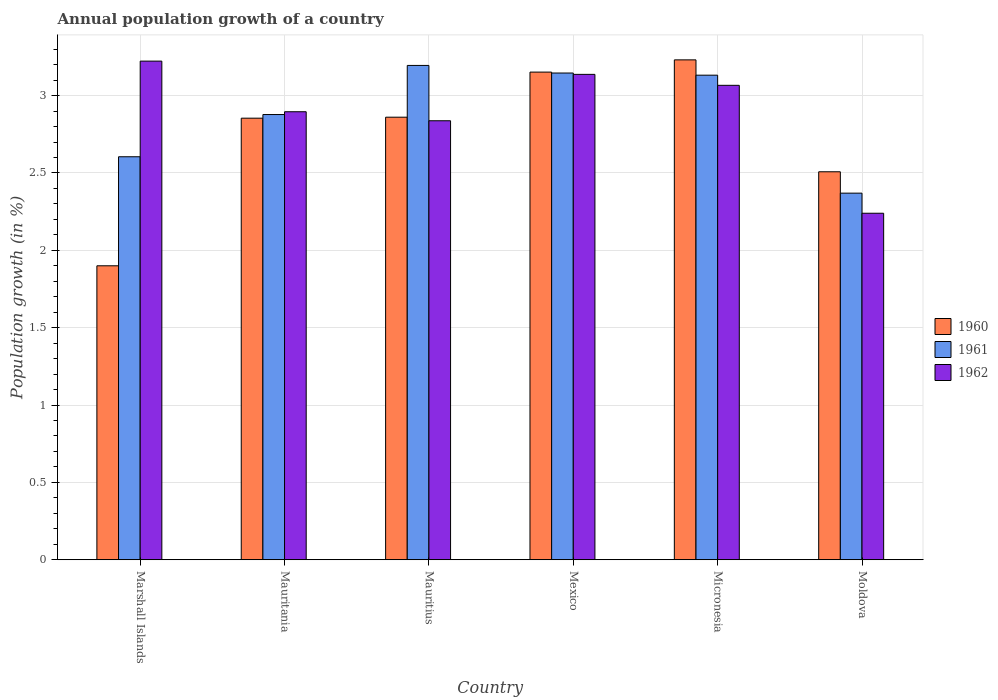How many different coloured bars are there?
Make the answer very short. 3. How many groups of bars are there?
Offer a terse response. 6. Are the number of bars on each tick of the X-axis equal?
Ensure brevity in your answer.  Yes. How many bars are there on the 1st tick from the right?
Your answer should be very brief. 3. What is the label of the 5th group of bars from the left?
Offer a very short reply. Micronesia. In how many cases, is the number of bars for a given country not equal to the number of legend labels?
Offer a terse response. 0. What is the annual population growth in 1962 in Mauritania?
Give a very brief answer. 2.9. Across all countries, what is the maximum annual population growth in 1962?
Make the answer very short. 3.22. Across all countries, what is the minimum annual population growth in 1962?
Offer a terse response. 2.24. In which country was the annual population growth in 1962 maximum?
Offer a terse response. Marshall Islands. In which country was the annual population growth in 1961 minimum?
Provide a short and direct response. Moldova. What is the total annual population growth in 1962 in the graph?
Offer a terse response. 17.4. What is the difference between the annual population growth in 1960 in Marshall Islands and that in Mauritania?
Keep it short and to the point. -0.95. What is the difference between the annual population growth in 1961 in Mexico and the annual population growth in 1960 in Mauritius?
Your answer should be very brief. 0.29. What is the average annual population growth in 1960 per country?
Offer a terse response. 2.75. What is the difference between the annual population growth of/in 1961 and annual population growth of/in 1960 in Mauritius?
Make the answer very short. 0.33. In how many countries, is the annual population growth in 1961 greater than 0.9 %?
Provide a short and direct response. 6. What is the ratio of the annual population growth in 1962 in Marshall Islands to that in Mauritania?
Offer a terse response. 1.11. What is the difference between the highest and the second highest annual population growth in 1961?
Give a very brief answer. -0.05. What is the difference between the highest and the lowest annual population growth in 1960?
Make the answer very short. 1.33. In how many countries, is the annual population growth in 1961 greater than the average annual population growth in 1961 taken over all countries?
Your response must be concise. 3. Is it the case that in every country, the sum of the annual population growth in 1962 and annual population growth in 1961 is greater than the annual population growth in 1960?
Your answer should be compact. Yes. How many bars are there?
Give a very brief answer. 18. Does the graph contain any zero values?
Give a very brief answer. No. How many legend labels are there?
Your answer should be very brief. 3. What is the title of the graph?
Your response must be concise. Annual population growth of a country. What is the label or title of the Y-axis?
Ensure brevity in your answer.  Population growth (in %). What is the Population growth (in %) in 1960 in Marshall Islands?
Your answer should be compact. 1.9. What is the Population growth (in %) of 1961 in Marshall Islands?
Provide a succinct answer. 2.6. What is the Population growth (in %) in 1962 in Marshall Islands?
Offer a terse response. 3.22. What is the Population growth (in %) of 1960 in Mauritania?
Keep it short and to the point. 2.85. What is the Population growth (in %) in 1961 in Mauritania?
Make the answer very short. 2.88. What is the Population growth (in %) of 1962 in Mauritania?
Give a very brief answer. 2.9. What is the Population growth (in %) of 1960 in Mauritius?
Make the answer very short. 2.86. What is the Population growth (in %) of 1961 in Mauritius?
Keep it short and to the point. 3.19. What is the Population growth (in %) of 1962 in Mauritius?
Your response must be concise. 2.84. What is the Population growth (in %) of 1960 in Mexico?
Offer a terse response. 3.15. What is the Population growth (in %) of 1961 in Mexico?
Your response must be concise. 3.15. What is the Population growth (in %) of 1962 in Mexico?
Offer a terse response. 3.14. What is the Population growth (in %) of 1960 in Micronesia?
Offer a very short reply. 3.23. What is the Population growth (in %) of 1961 in Micronesia?
Ensure brevity in your answer.  3.13. What is the Population growth (in %) of 1962 in Micronesia?
Ensure brevity in your answer.  3.07. What is the Population growth (in %) in 1960 in Moldova?
Provide a succinct answer. 2.51. What is the Population growth (in %) of 1961 in Moldova?
Your answer should be very brief. 2.37. What is the Population growth (in %) in 1962 in Moldova?
Offer a terse response. 2.24. Across all countries, what is the maximum Population growth (in %) in 1960?
Provide a short and direct response. 3.23. Across all countries, what is the maximum Population growth (in %) in 1961?
Your response must be concise. 3.19. Across all countries, what is the maximum Population growth (in %) in 1962?
Ensure brevity in your answer.  3.22. Across all countries, what is the minimum Population growth (in %) of 1960?
Provide a short and direct response. 1.9. Across all countries, what is the minimum Population growth (in %) of 1961?
Your answer should be compact. 2.37. Across all countries, what is the minimum Population growth (in %) of 1962?
Your answer should be very brief. 2.24. What is the total Population growth (in %) in 1960 in the graph?
Make the answer very short. 16.5. What is the total Population growth (in %) in 1961 in the graph?
Your answer should be compact. 17.32. What is the total Population growth (in %) of 1962 in the graph?
Offer a very short reply. 17.4. What is the difference between the Population growth (in %) of 1960 in Marshall Islands and that in Mauritania?
Provide a succinct answer. -0.95. What is the difference between the Population growth (in %) of 1961 in Marshall Islands and that in Mauritania?
Offer a very short reply. -0.27. What is the difference between the Population growth (in %) of 1962 in Marshall Islands and that in Mauritania?
Your response must be concise. 0.33. What is the difference between the Population growth (in %) in 1960 in Marshall Islands and that in Mauritius?
Give a very brief answer. -0.96. What is the difference between the Population growth (in %) of 1961 in Marshall Islands and that in Mauritius?
Ensure brevity in your answer.  -0.59. What is the difference between the Population growth (in %) in 1962 in Marshall Islands and that in Mauritius?
Your response must be concise. 0.39. What is the difference between the Population growth (in %) of 1960 in Marshall Islands and that in Mexico?
Make the answer very short. -1.25. What is the difference between the Population growth (in %) of 1961 in Marshall Islands and that in Mexico?
Provide a succinct answer. -0.54. What is the difference between the Population growth (in %) in 1962 in Marshall Islands and that in Mexico?
Give a very brief answer. 0.09. What is the difference between the Population growth (in %) in 1960 in Marshall Islands and that in Micronesia?
Your answer should be compact. -1.33. What is the difference between the Population growth (in %) in 1961 in Marshall Islands and that in Micronesia?
Provide a succinct answer. -0.53. What is the difference between the Population growth (in %) of 1962 in Marshall Islands and that in Micronesia?
Give a very brief answer. 0.16. What is the difference between the Population growth (in %) of 1960 in Marshall Islands and that in Moldova?
Make the answer very short. -0.61. What is the difference between the Population growth (in %) in 1961 in Marshall Islands and that in Moldova?
Offer a terse response. 0.24. What is the difference between the Population growth (in %) of 1962 in Marshall Islands and that in Moldova?
Give a very brief answer. 0.98. What is the difference between the Population growth (in %) of 1960 in Mauritania and that in Mauritius?
Provide a succinct answer. -0.01. What is the difference between the Population growth (in %) of 1961 in Mauritania and that in Mauritius?
Offer a terse response. -0.32. What is the difference between the Population growth (in %) of 1962 in Mauritania and that in Mauritius?
Provide a short and direct response. 0.06. What is the difference between the Population growth (in %) in 1960 in Mauritania and that in Mexico?
Keep it short and to the point. -0.3. What is the difference between the Population growth (in %) in 1961 in Mauritania and that in Mexico?
Your response must be concise. -0.27. What is the difference between the Population growth (in %) in 1962 in Mauritania and that in Mexico?
Ensure brevity in your answer.  -0.24. What is the difference between the Population growth (in %) of 1960 in Mauritania and that in Micronesia?
Give a very brief answer. -0.38. What is the difference between the Population growth (in %) of 1961 in Mauritania and that in Micronesia?
Offer a terse response. -0.25. What is the difference between the Population growth (in %) of 1962 in Mauritania and that in Micronesia?
Your response must be concise. -0.17. What is the difference between the Population growth (in %) of 1960 in Mauritania and that in Moldova?
Ensure brevity in your answer.  0.35. What is the difference between the Population growth (in %) of 1961 in Mauritania and that in Moldova?
Your answer should be very brief. 0.51. What is the difference between the Population growth (in %) in 1962 in Mauritania and that in Moldova?
Make the answer very short. 0.66. What is the difference between the Population growth (in %) in 1960 in Mauritius and that in Mexico?
Give a very brief answer. -0.29. What is the difference between the Population growth (in %) of 1961 in Mauritius and that in Mexico?
Your response must be concise. 0.05. What is the difference between the Population growth (in %) of 1962 in Mauritius and that in Mexico?
Provide a succinct answer. -0.3. What is the difference between the Population growth (in %) in 1960 in Mauritius and that in Micronesia?
Offer a very short reply. -0.37. What is the difference between the Population growth (in %) in 1961 in Mauritius and that in Micronesia?
Provide a succinct answer. 0.06. What is the difference between the Population growth (in %) in 1962 in Mauritius and that in Micronesia?
Offer a very short reply. -0.23. What is the difference between the Population growth (in %) of 1960 in Mauritius and that in Moldova?
Give a very brief answer. 0.35. What is the difference between the Population growth (in %) in 1961 in Mauritius and that in Moldova?
Give a very brief answer. 0.83. What is the difference between the Population growth (in %) in 1962 in Mauritius and that in Moldova?
Offer a terse response. 0.6. What is the difference between the Population growth (in %) of 1960 in Mexico and that in Micronesia?
Your answer should be compact. -0.08. What is the difference between the Population growth (in %) in 1961 in Mexico and that in Micronesia?
Keep it short and to the point. 0.01. What is the difference between the Population growth (in %) of 1962 in Mexico and that in Micronesia?
Give a very brief answer. 0.07. What is the difference between the Population growth (in %) in 1960 in Mexico and that in Moldova?
Provide a short and direct response. 0.64. What is the difference between the Population growth (in %) in 1961 in Mexico and that in Moldova?
Provide a short and direct response. 0.78. What is the difference between the Population growth (in %) in 1962 in Mexico and that in Moldova?
Offer a terse response. 0.9. What is the difference between the Population growth (in %) of 1960 in Micronesia and that in Moldova?
Give a very brief answer. 0.72. What is the difference between the Population growth (in %) in 1961 in Micronesia and that in Moldova?
Your answer should be very brief. 0.76. What is the difference between the Population growth (in %) in 1962 in Micronesia and that in Moldova?
Provide a short and direct response. 0.83. What is the difference between the Population growth (in %) of 1960 in Marshall Islands and the Population growth (in %) of 1961 in Mauritania?
Offer a terse response. -0.98. What is the difference between the Population growth (in %) of 1960 in Marshall Islands and the Population growth (in %) of 1962 in Mauritania?
Provide a succinct answer. -1. What is the difference between the Population growth (in %) in 1961 in Marshall Islands and the Population growth (in %) in 1962 in Mauritania?
Make the answer very short. -0.29. What is the difference between the Population growth (in %) in 1960 in Marshall Islands and the Population growth (in %) in 1961 in Mauritius?
Provide a short and direct response. -1.29. What is the difference between the Population growth (in %) in 1960 in Marshall Islands and the Population growth (in %) in 1962 in Mauritius?
Give a very brief answer. -0.94. What is the difference between the Population growth (in %) of 1961 in Marshall Islands and the Population growth (in %) of 1962 in Mauritius?
Give a very brief answer. -0.23. What is the difference between the Population growth (in %) in 1960 in Marshall Islands and the Population growth (in %) in 1961 in Mexico?
Offer a terse response. -1.25. What is the difference between the Population growth (in %) in 1960 in Marshall Islands and the Population growth (in %) in 1962 in Mexico?
Your answer should be very brief. -1.24. What is the difference between the Population growth (in %) of 1961 in Marshall Islands and the Population growth (in %) of 1962 in Mexico?
Keep it short and to the point. -0.53. What is the difference between the Population growth (in %) of 1960 in Marshall Islands and the Population growth (in %) of 1961 in Micronesia?
Provide a succinct answer. -1.23. What is the difference between the Population growth (in %) of 1960 in Marshall Islands and the Population growth (in %) of 1962 in Micronesia?
Make the answer very short. -1.17. What is the difference between the Population growth (in %) in 1961 in Marshall Islands and the Population growth (in %) in 1962 in Micronesia?
Ensure brevity in your answer.  -0.46. What is the difference between the Population growth (in %) in 1960 in Marshall Islands and the Population growth (in %) in 1961 in Moldova?
Provide a short and direct response. -0.47. What is the difference between the Population growth (in %) in 1960 in Marshall Islands and the Population growth (in %) in 1962 in Moldova?
Your answer should be very brief. -0.34. What is the difference between the Population growth (in %) in 1961 in Marshall Islands and the Population growth (in %) in 1962 in Moldova?
Your response must be concise. 0.37. What is the difference between the Population growth (in %) of 1960 in Mauritania and the Population growth (in %) of 1961 in Mauritius?
Your answer should be compact. -0.34. What is the difference between the Population growth (in %) of 1960 in Mauritania and the Population growth (in %) of 1962 in Mauritius?
Provide a short and direct response. 0.02. What is the difference between the Population growth (in %) in 1961 in Mauritania and the Population growth (in %) in 1962 in Mauritius?
Your response must be concise. 0.04. What is the difference between the Population growth (in %) in 1960 in Mauritania and the Population growth (in %) in 1961 in Mexico?
Give a very brief answer. -0.29. What is the difference between the Population growth (in %) of 1960 in Mauritania and the Population growth (in %) of 1962 in Mexico?
Provide a short and direct response. -0.28. What is the difference between the Population growth (in %) of 1961 in Mauritania and the Population growth (in %) of 1962 in Mexico?
Make the answer very short. -0.26. What is the difference between the Population growth (in %) in 1960 in Mauritania and the Population growth (in %) in 1961 in Micronesia?
Your response must be concise. -0.28. What is the difference between the Population growth (in %) in 1960 in Mauritania and the Population growth (in %) in 1962 in Micronesia?
Provide a succinct answer. -0.21. What is the difference between the Population growth (in %) in 1961 in Mauritania and the Population growth (in %) in 1962 in Micronesia?
Your answer should be compact. -0.19. What is the difference between the Population growth (in %) of 1960 in Mauritania and the Population growth (in %) of 1961 in Moldova?
Give a very brief answer. 0.48. What is the difference between the Population growth (in %) of 1960 in Mauritania and the Population growth (in %) of 1962 in Moldova?
Give a very brief answer. 0.61. What is the difference between the Population growth (in %) in 1961 in Mauritania and the Population growth (in %) in 1962 in Moldova?
Make the answer very short. 0.64. What is the difference between the Population growth (in %) of 1960 in Mauritius and the Population growth (in %) of 1961 in Mexico?
Your answer should be compact. -0.29. What is the difference between the Population growth (in %) in 1960 in Mauritius and the Population growth (in %) in 1962 in Mexico?
Make the answer very short. -0.28. What is the difference between the Population growth (in %) in 1961 in Mauritius and the Population growth (in %) in 1962 in Mexico?
Offer a terse response. 0.06. What is the difference between the Population growth (in %) in 1960 in Mauritius and the Population growth (in %) in 1961 in Micronesia?
Your answer should be compact. -0.27. What is the difference between the Population growth (in %) in 1960 in Mauritius and the Population growth (in %) in 1962 in Micronesia?
Provide a short and direct response. -0.21. What is the difference between the Population growth (in %) of 1961 in Mauritius and the Population growth (in %) of 1962 in Micronesia?
Offer a terse response. 0.13. What is the difference between the Population growth (in %) of 1960 in Mauritius and the Population growth (in %) of 1961 in Moldova?
Offer a terse response. 0.49. What is the difference between the Population growth (in %) in 1960 in Mauritius and the Population growth (in %) in 1962 in Moldova?
Your response must be concise. 0.62. What is the difference between the Population growth (in %) in 1961 in Mauritius and the Population growth (in %) in 1962 in Moldova?
Ensure brevity in your answer.  0.96. What is the difference between the Population growth (in %) in 1960 in Mexico and the Population growth (in %) in 1961 in Micronesia?
Your answer should be very brief. 0.02. What is the difference between the Population growth (in %) of 1960 in Mexico and the Population growth (in %) of 1962 in Micronesia?
Offer a terse response. 0.09. What is the difference between the Population growth (in %) of 1961 in Mexico and the Population growth (in %) of 1962 in Micronesia?
Provide a succinct answer. 0.08. What is the difference between the Population growth (in %) in 1960 in Mexico and the Population growth (in %) in 1961 in Moldova?
Offer a very short reply. 0.78. What is the difference between the Population growth (in %) in 1960 in Mexico and the Population growth (in %) in 1962 in Moldova?
Your response must be concise. 0.91. What is the difference between the Population growth (in %) of 1961 in Mexico and the Population growth (in %) of 1962 in Moldova?
Ensure brevity in your answer.  0.91. What is the difference between the Population growth (in %) of 1960 in Micronesia and the Population growth (in %) of 1961 in Moldova?
Give a very brief answer. 0.86. What is the difference between the Population growth (in %) of 1961 in Micronesia and the Population growth (in %) of 1962 in Moldova?
Give a very brief answer. 0.89. What is the average Population growth (in %) of 1960 per country?
Provide a short and direct response. 2.75. What is the average Population growth (in %) of 1961 per country?
Your response must be concise. 2.89. What is the average Population growth (in %) in 1962 per country?
Offer a very short reply. 2.9. What is the difference between the Population growth (in %) of 1960 and Population growth (in %) of 1961 in Marshall Islands?
Your answer should be very brief. -0.7. What is the difference between the Population growth (in %) of 1960 and Population growth (in %) of 1962 in Marshall Islands?
Your answer should be compact. -1.32. What is the difference between the Population growth (in %) of 1961 and Population growth (in %) of 1962 in Marshall Islands?
Provide a succinct answer. -0.62. What is the difference between the Population growth (in %) of 1960 and Population growth (in %) of 1961 in Mauritania?
Provide a short and direct response. -0.02. What is the difference between the Population growth (in %) in 1960 and Population growth (in %) in 1962 in Mauritania?
Your answer should be very brief. -0.04. What is the difference between the Population growth (in %) of 1961 and Population growth (in %) of 1962 in Mauritania?
Offer a terse response. -0.02. What is the difference between the Population growth (in %) in 1960 and Population growth (in %) in 1961 in Mauritius?
Your answer should be compact. -0.33. What is the difference between the Population growth (in %) of 1960 and Population growth (in %) of 1962 in Mauritius?
Your response must be concise. 0.02. What is the difference between the Population growth (in %) in 1961 and Population growth (in %) in 1962 in Mauritius?
Offer a terse response. 0.36. What is the difference between the Population growth (in %) of 1960 and Population growth (in %) of 1961 in Mexico?
Your response must be concise. 0.01. What is the difference between the Population growth (in %) of 1960 and Population growth (in %) of 1962 in Mexico?
Provide a succinct answer. 0.01. What is the difference between the Population growth (in %) in 1961 and Population growth (in %) in 1962 in Mexico?
Your response must be concise. 0.01. What is the difference between the Population growth (in %) in 1960 and Population growth (in %) in 1961 in Micronesia?
Give a very brief answer. 0.1. What is the difference between the Population growth (in %) in 1960 and Population growth (in %) in 1962 in Micronesia?
Offer a very short reply. 0.16. What is the difference between the Population growth (in %) of 1961 and Population growth (in %) of 1962 in Micronesia?
Make the answer very short. 0.07. What is the difference between the Population growth (in %) in 1960 and Population growth (in %) in 1961 in Moldova?
Your answer should be very brief. 0.14. What is the difference between the Population growth (in %) in 1960 and Population growth (in %) in 1962 in Moldova?
Your answer should be compact. 0.27. What is the difference between the Population growth (in %) in 1961 and Population growth (in %) in 1962 in Moldova?
Ensure brevity in your answer.  0.13. What is the ratio of the Population growth (in %) in 1960 in Marshall Islands to that in Mauritania?
Offer a very short reply. 0.67. What is the ratio of the Population growth (in %) of 1961 in Marshall Islands to that in Mauritania?
Give a very brief answer. 0.91. What is the ratio of the Population growth (in %) in 1962 in Marshall Islands to that in Mauritania?
Offer a terse response. 1.11. What is the ratio of the Population growth (in %) of 1960 in Marshall Islands to that in Mauritius?
Your response must be concise. 0.66. What is the ratio of the Population growth (in %) in 1961 in Marshall Islands to that in Mauritius?
Your answer should be very brief. 0.82. What is the ratio of the Population growth (in %) of 1962 in Marshall Islands to that in Mauritius?
Offer a terse response. 1.14. What is the ratio of the Population growth (in %) of 1960 in Marshall Islands to that in Mexico?
Offer a terse response. 0.6. What is the ratio of the Population growth (in %) in 1961 in Marshall Islands to that in Mexico?
Offer a terse response. 0.83. What is the ratio of the Population growth (in %) in 1962 in Marshall Islands to that in Mexico?
Offer a very short reply. 1.03. What is the ratio of the Population growth (in %) in 1960 in Marshall Islands to that in Micronesia?
Keep it short and to the point. 0.59. What is the ratio of the Population growth (in %) in 1961 in Marshall Islands to that in Micronesia?
Keep it short and to the point. 0.83. What is the ratio of the Population growth (in %) of 1962 in Marshall Islands to that in Micronesia?
Give a very brief answer. 1.05. What is the ratio of the Population growth (in %) in 1960 in Marshall Islands to that in Moldova?
Give a very brief answer. 0.76. What is the ratio of the Population growth (in %) in 1961 in Marshall Islands to that in Moldova?
Offer a terse response. 1.1. What is the ratio of the Population growth (in %) in 1962 in Marshall Islands to that in Moldova?
Offer a very short reply. 1.44. What is the ratio of the Population growth (in %) in 1961 in Mauritania to that in Mauritius?
Offer a terse response. 0.9. What is the ratio of the Population growth (in %) in 1962 in Mauritania to that in Mauritius?
Ensure brevity in your answer.  1.02. What is the ratio of the Population growth (in %) of 1960 in Mauritania to that in Mexico?
Offer a terse response. 0.91. What is the ratio of the Population growth (in %) in 1961 in Mauritania to that in Mexico?
Your answer should be compact. 0.91. What is the ratio of the Population growth (in %) of 1962 in Mauritania to that in Mexico?
Provide a succinct answer. 0.92. What is the ratio of the Population growth (in %) in 1960 in Mauritania to that in Micronesia?
Offer a terse response. 0.88. What is the ratio of the Population growth (in %) in 1961 in Mauritania to that in Micronesia?
Make the answer very short. 0.92. What is the ratio of the Population growth (in %) of 1962 in Mauritania to that in Micronesia?
Your answer should be compact. 0.94. What is the ratio of the Population growth (in %) in 1960 in Mauritania to that in Moldova?
Offer a very short reply. 1.14. What is the ratio of the Population growth (in %) in 1961 in Mauritania to that in Moldova?
Offer a very short reply. 1.21. What is the ratio of the Population growth (in %) in 1962 in Mauritania to that in Moldova?
Your response must be concise. 1.29. What is the ratio of the Population growth (in %) in 1960 in Mauritius to that in Mexico?
Your response must be concise. 0.91. What is the ratio of the Population growth (in %) of 1961 in Mauritius to that in Mexico?
Your answer should be very brief. 1.02. What is the ratio of the Population growth (in %) in 1962 in Mauritius to that in Mexico?
Your answer should be compact. 0.9. What is the ratio of the Population growth (in %) of 1960 in Mauritius to that in Micronesia?
Your response must be concise. 0.89. What is the ratio of the Population growth (in %) of 1961 in Mauritius to that in Micronesia?
Make the answer very short. 1.02. What is the ratio of the Population growth (in %) in 1962 in Mauritius to that in Micronesia?
Your response must be concise. 0.93. What is the ratio of the Population growth (in %) of 1960 in Mauritius to that in Moldova?
Give a very brief answer. 1.14. What is the ratio of the Population growth (in %) of 1961 in Mauritius to that in Moldova?
Provide a short and direct response. 1.35. What is the ratio of the Population growth (in %) of 1962 in Mauritius to that in Moldova?
Your answer should be compact. 1.27. What is the ratio of the Population growth (in %) in 1960 in Mexico to that in Micronesia?
Provide a short and direct response. 0.98. What is the ratio of the Population growth (in %) in 1962 in Mexico to that in Micronesia?
Make the answer very short. 1.02. What is the ratio of the Population growth (in %) of 1960 in Mexico to that in Moldova?
Offer a very short reply. 1.26. What is the ratio of the Population growth (in %) in 1961 in Mexico to that in Moldova?
Offer a very short reply. 1.33. What is the ratio of the Population growth (in %) of 1962 in Mexico to that in Moldova?
Your answer should be compact. 1.4. What is the ratio of the Population growth (in %) of 1960 in Micronesia to that in Moldova?
Your response must be concise. 1.29. What is the ratio of the Population growth (in %) in 1961 in Micronesia to that in Moldova?
Your answer should be compact. 1.32. What is the ratio of the Population growth (in %) in 1962 in Micronesia to that in Moldova?
Your answer should be compact. 1.37. What is the difference between the highest and the second highest Population growth (in %) of 1960?
Ensure brevity in your answer.  0.08. What is the difference between the highest and the second highest Population growth (in %) in 1961?
Provide a succinct answer. 0.05. What is the difference between the highest and the second highest Population growth (in %) in 1962?
Your answer should be compact. 0.09. What is the difference between the highest and the lowest Population growth (in %) in 1960?
Provide a succinct answer. 1.33. What is the difference between the highest and the lowest Population growth (in %) in 1961?
Provide a succinct answer. 0.83. What is the difference between the highest and the lowest Population growth (in %) of 1962?
Offer a terse response. 0.98. 